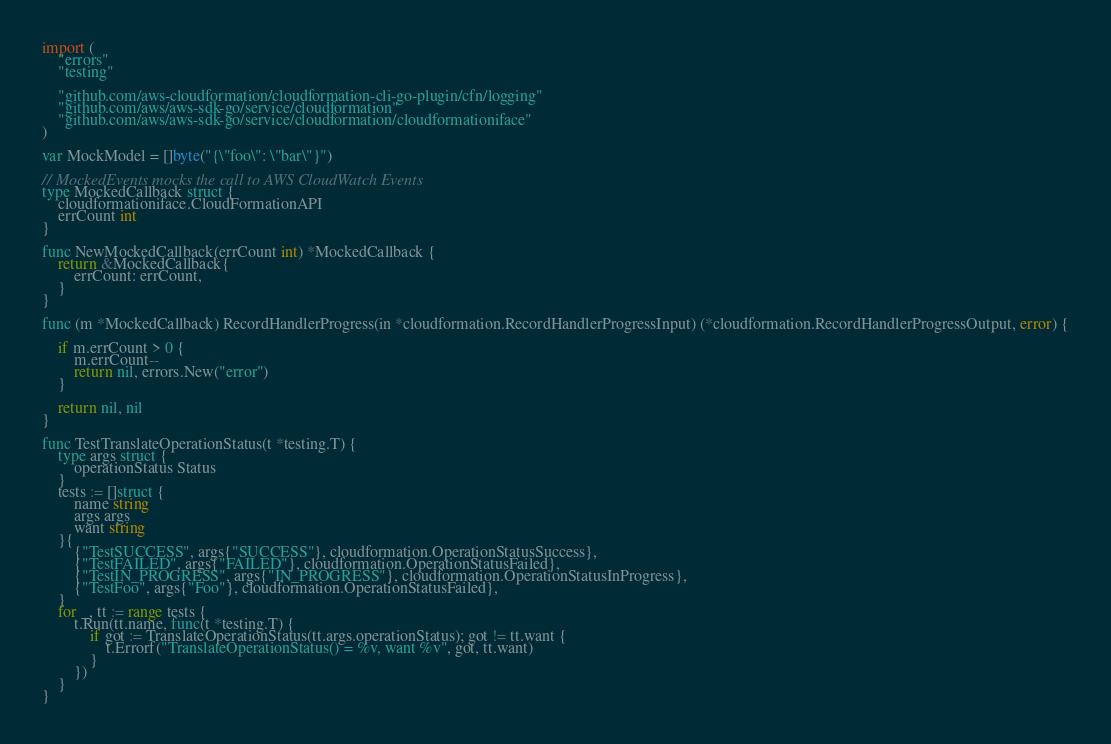Convert code to text. <code><loc_0><loc_0><loc_500><loc_500><_Go_>
import (
	"errors"
	"testing"

	"github.com/aws-cloudformation/cloudformation-cli-go-plugin/cfn/logging"
	"github.com/aws/aws-sdk-go/service/cloudformation"
	"github.com/aws/aws-sdk-go/service/cloudformation/cloudformationiface"
)

var MockModel = []byte("{\"foo\": \"bar\"}")

// MockedEvents mocks the call to AWS CloudWatch Events
type MockedCallback struct {
	cloudformationiface.CloudFormationAPI
	errCount int
}

func NewMockedCallback(errCount int) *MockedCallback {
	return &MockedCallback{
		errCount: errCount,
	}
}

func (m *MockedCallback) RecordHandlerProgress(in *cloudformation.RecordHandlerProgressInput) (*cloudformation.RecordHandlerProgressOutput, error) {

	if m.errCount > 0 {
		m.errCount--
		return nil, errors.New("error")
	}

	return nil, nil
}

func TestTranslateOperationStatus(t *testing.T) {
	type args struct {
		operationStatus Status
	}
	tests := []struct {
		name string
		args args
		want string
	}{
		{"TestSUCCESS", args{"SUCCESS"}, cloudformation.OperationStatusSuccess},
		{"TestFAILED", args{"FAILED"}, cloudformation.OperationStatusFailed},
		{"TestIN_PROGRESS", args{"IN_PROGRESS"}, cloudformation.OperationStatusInProgress},
		{"TestFoo", args{"Foo"}, cloudformation.OperationStatusFailed},
	}
	for _, tt := range tests {
		t.Run(tt.name, func(t *testing.T) {
			if got := TranslateOperationStatus(tt.args.operationStatus); got != tt.want {
				t.Errorf("TranslateOperationStatus() = %v, want %v", got, tt.want)
			}
		})
	}
}
</code> 